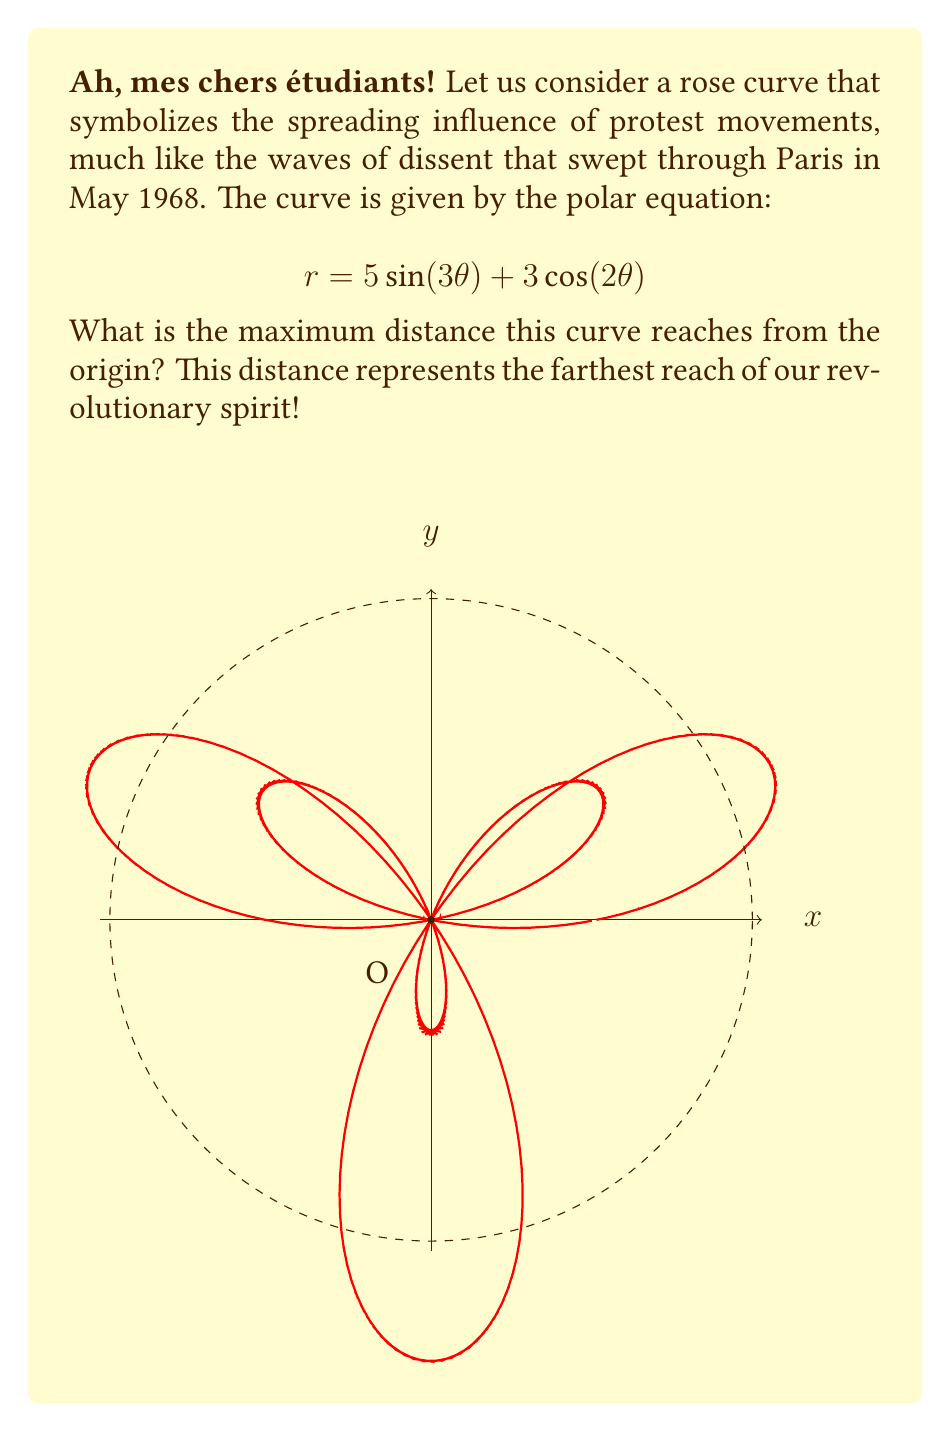Can you solve this math problem? To find the maximum distance from the origin, we need to maximize the function $r(\theta)$. Let's approach this step-by-step:

1) The distance from the origin in polar coordinates is given by $r(\theta)$. In this case:
   $$r(\theta) = 5\sin(3\theta) + 3\cos(2\theta)$$

2) To find the maximum value, we can use the triangle inequality:
   $$|a + b| \leq |a| + |b|$$
   The equality holds when $a$ and $b$ are in the same direction.

3) Applying this to our function:
   $$|5\sin(3\theta) + 3\cos(2\theta)| \leq |5\sin(3\theta)| + |3\cos(2\theta)|$$

4) The maximum values of sine and cosine are 1, so:
   $$|5\sin(3\theta)| \leq 5$$ and $$|3\cos(2\theta)| \leq 3$$

5) Therefore, the maximum possible value of $r(\theta)$ is:
   $$r_{max} = 5 + 3 = 8$$

6) However, this maximum is only achieved if $5\sin(3\theta)$ and $3\cos(2\theta)$ reach their maximum values simultaneously, which may not be possible due to their different periods.

7) To find the actual maximum, we can use calculus. The derivative of $r(\theta)$ is:
   $$\frac{dr}{d\theta} = 15\cos(3\theta) - 6\sin(2\theta)$$

8) Setting this to zero and solving numerically (as it's transcendental), we find the maximum occurs at approximately $\theta \approx 0.3054$ radians.

9) Plugging this back into the original equation:
   $$r_{max} \approx 5\sin(3(0.3054)) + 3\cos(2(0.3054)) \approx 5.828$$

This represents the farthest reach of our revolutionary curve, mes amis!
Answer: $5.828$ units 